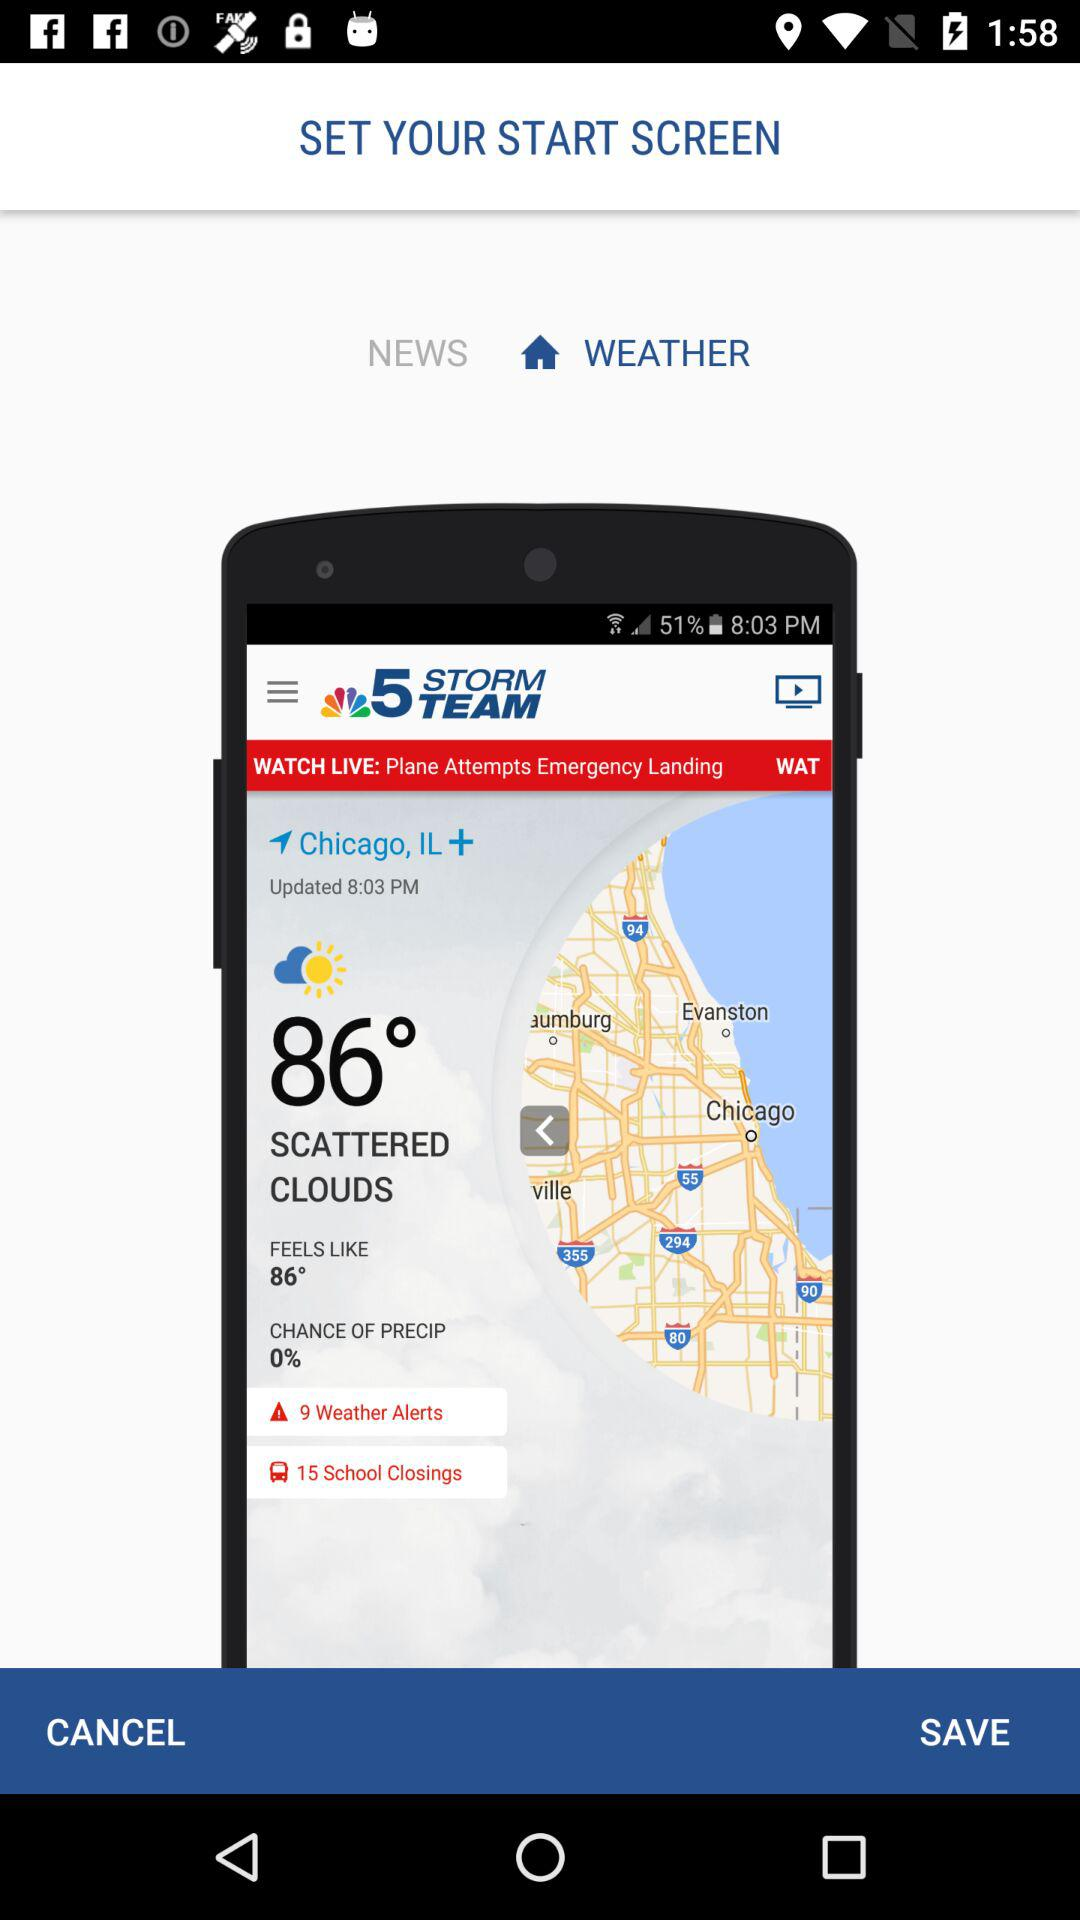What is the temperature in Chicago? The temperature is 86°. 